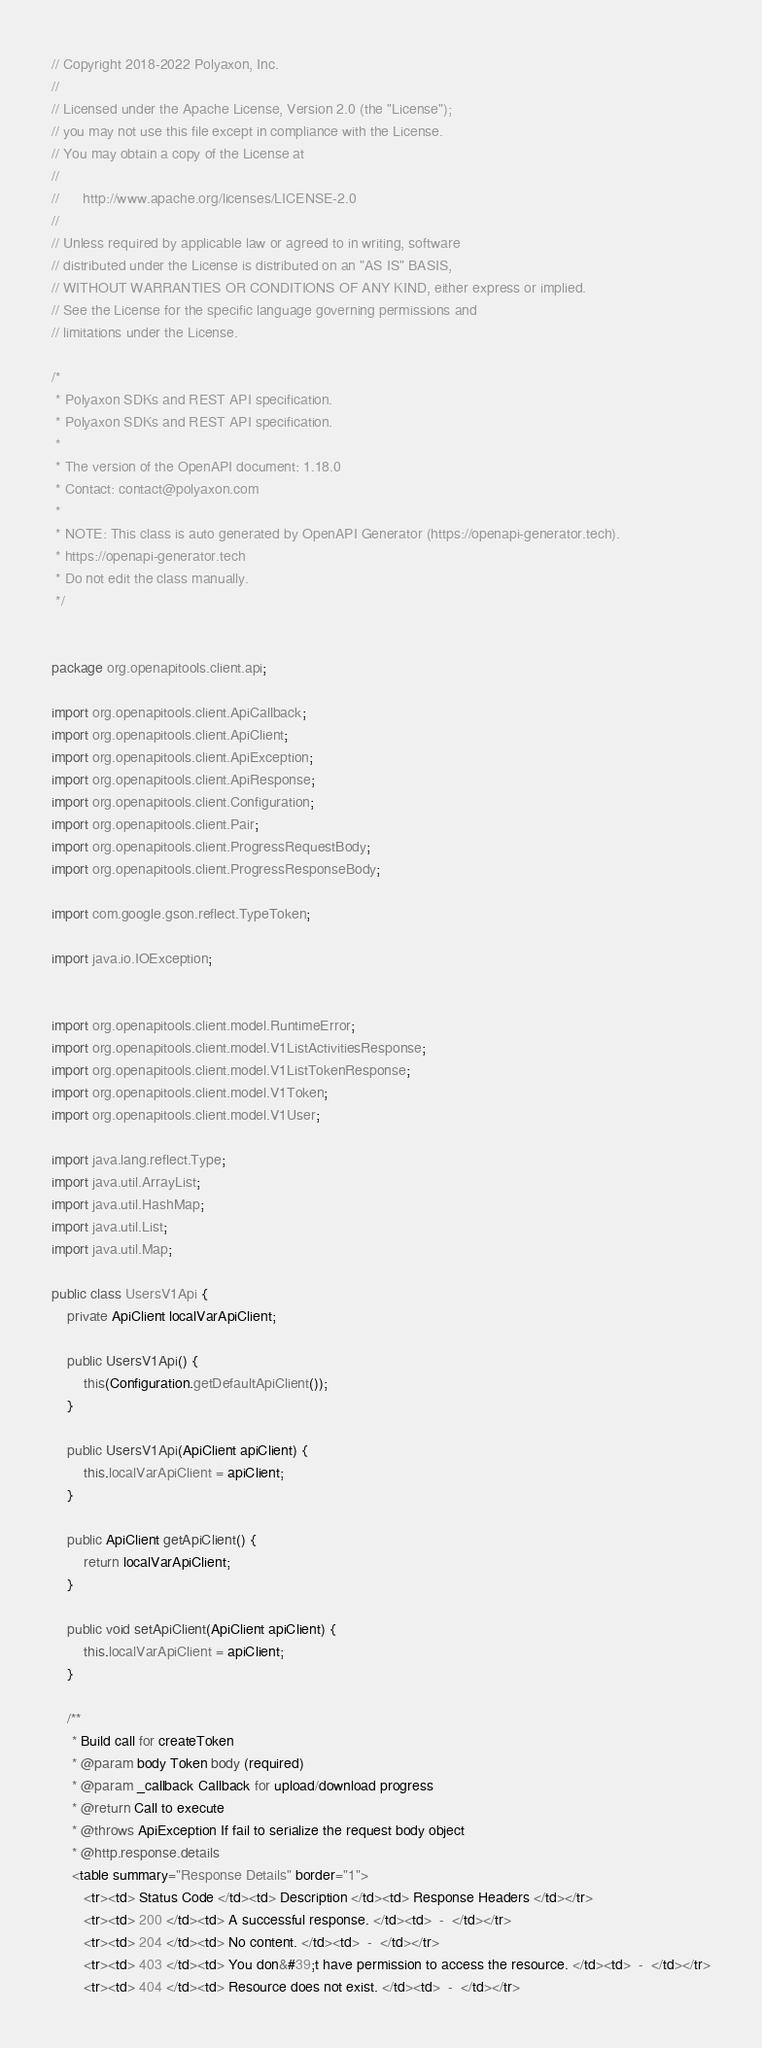Convert code to text. <code><loc_0><loc_0><loc_500><loc_500><_Java_>// Copyright 2018-2022 Polyaxon, Inc.
//
// Licensed under the Apache License, Version 2.0 (the "License");
// you may not use this file except in compliance with the License.
// You may obtain a copy of the License at
//
//      http://www.apache.org/licenses/LICENSE-2.0
//
// Unless required by applicable law or agreed to in writing, software
// distributed under the License is distributed on an "AS IS" BASIS,
// WITHOUT WARRANTIES OR CONDITIONS OF ANY KIND, either express or implied.
// See the License for the specific language governing permissions and
// limitations under the License.

/*
 * Polyaxon SDKs and REST API specification.
 * Polyaxon SDKs and REST API specification.
 *
 * The version of the OpenAPI document: 1.18.0
 * Contact: contact@polyaxon.com
 *
 * NOTE: This class is auto generated by OpenAPI Generator (https://openapi-generator.tech).
 * https://openapi-generator.tech
 * Do not edit the class manually.
 */


package org.openapitools.client.api;

import org.openapitools.client.ApiCallback;
import org.openapitools.client.ApiClient;
import org.openapitools.client.ApiException;
import org.openapitools.client.ApiResponse;
import org.openapitools.client.Configuration;
import org.openapitools.client.Pair;
import org.openapitools.client.ProgressRequestBody;
import org.openapitools.client.ProgressResponseBody;

import com.google.gson.reflect.TypeToken;

import java.io.IOException;


import org.openapitools.client.model.RuntimeError;
import org.openapitools.client.model.V1ListActivitiesResponse;
import org.openapitools.client.model.V1ListTokenResponse;
import org.openapitools.client.model.V1Token;
import org.openapitools.client.model.V1User;

import java.lang.reflect.Type;
import java.util.ArrayList;
import java.util.HashMap;
import java.util.List;
import java.util.Map;

public class UsersV1Api {
    private ApiClient localVarApiClient;

    public UsersV1Api() {
        this(Configuration.getDefaultApiClient());
    }

    public UsersV1Api(ApiClient apiClient) {
        this.localVarApiClient = apiClient;
    }

    public ApiClient getApiClient() {
        return localVarApiClient;
    }

    public void setApiClient(ApiClient apiClient) {
        this.localVarApiClient = apiClient;
    }

    /**
     * Build call for createToken
     * @param body Token body (required)
     * @param _callback Callback for upload/download progress
     * @return Call to execute
     * @throws ApiException If fail to serialize the request body object
     * @http.response.details
     <table summary="Response Details" border="1">
        <tr><td> Status Code </td><td> Description </td><td> Response Headers </td></tr>
        <tr><td> 200 </td><td> A successful response. </td><td>  -  </td></tr>
        <tr><td> 204 </td><td> No content. </td><td>  -  </td></tr>
        <tr><td> 403 </td><td> You don&#39;t have permission to access the resource. </td><td>  -  </td></tr>
        <tr><td> 404 </td><td> Resource does not exist. </td><td>  -  </td></tr></code> 